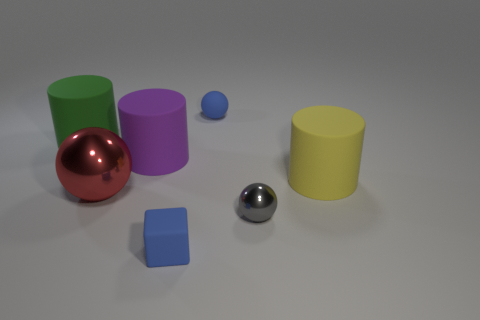What is the shape of the tiny thing that is the same color as the small rubber cube?
Make the answer very short. Sphere. Is the number of green rubber cylinders to the left of the green rubber cylinder less than the number of yellow objects?
Keep it short and to the point. Yes. What number of rubber cubes are in front of the big red sphere?
Offer a very short reply. 1. What size is the object that is to the right of the metallic thing that is in front of the metal thing that is to the left of the small metallic sphere?
Ensure brevity in your answer.  Large. Do the large green rubber thing and the matte object to the right of the tiny blue sphere have the same shape?
Provide a short and direct response. Yes. There is a cube that is made of the same material as the yellow cylinder; what size is it?
Your answer should be compact. Small. Is there any other thing of the same color as the tiny metallic ball?
Provide a succinct answer. No. The small ball in front of the object that is behind the large cylinder behind the big purple matte thing is made of what material?
Provide a succinct answer. Metal. How many metallic things are either blue blocks or tiny gray blocks?
Offer a terse response. 0. Is the color of the rubber sphere the same as the matte cube?
Ensure brevity in your answer.  Yes. 